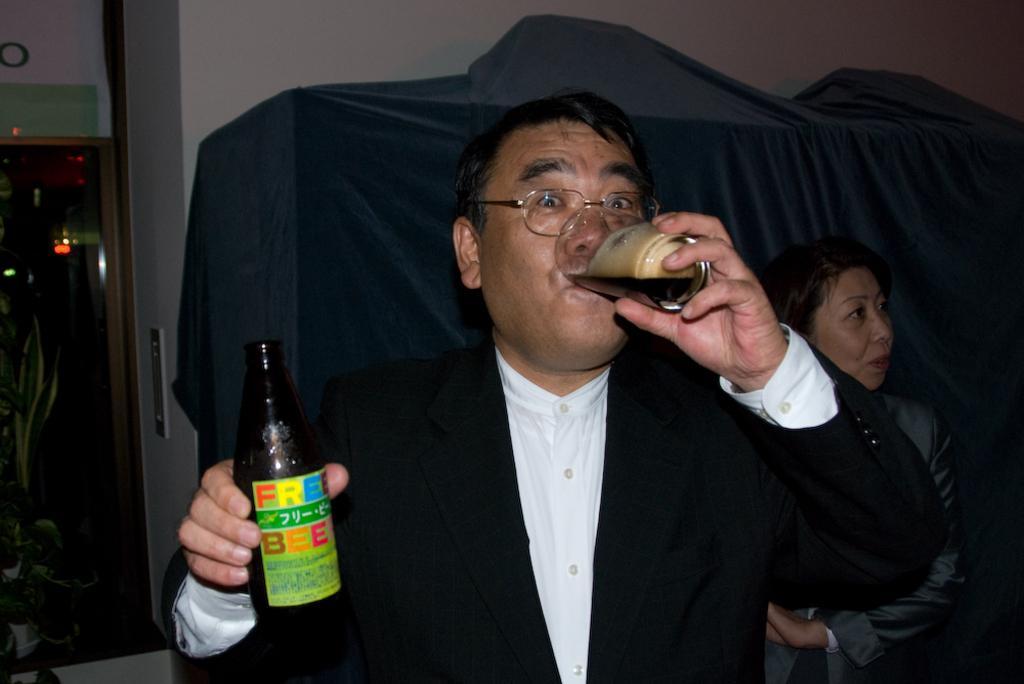Can you describe this image briefly? In this picture we can see a man wore blazer, spectacle drinking with glass holding in one hand and on other hand bottle and at back of him we can see a woman standing and in the background we can see wall, door, lights, cloth. 